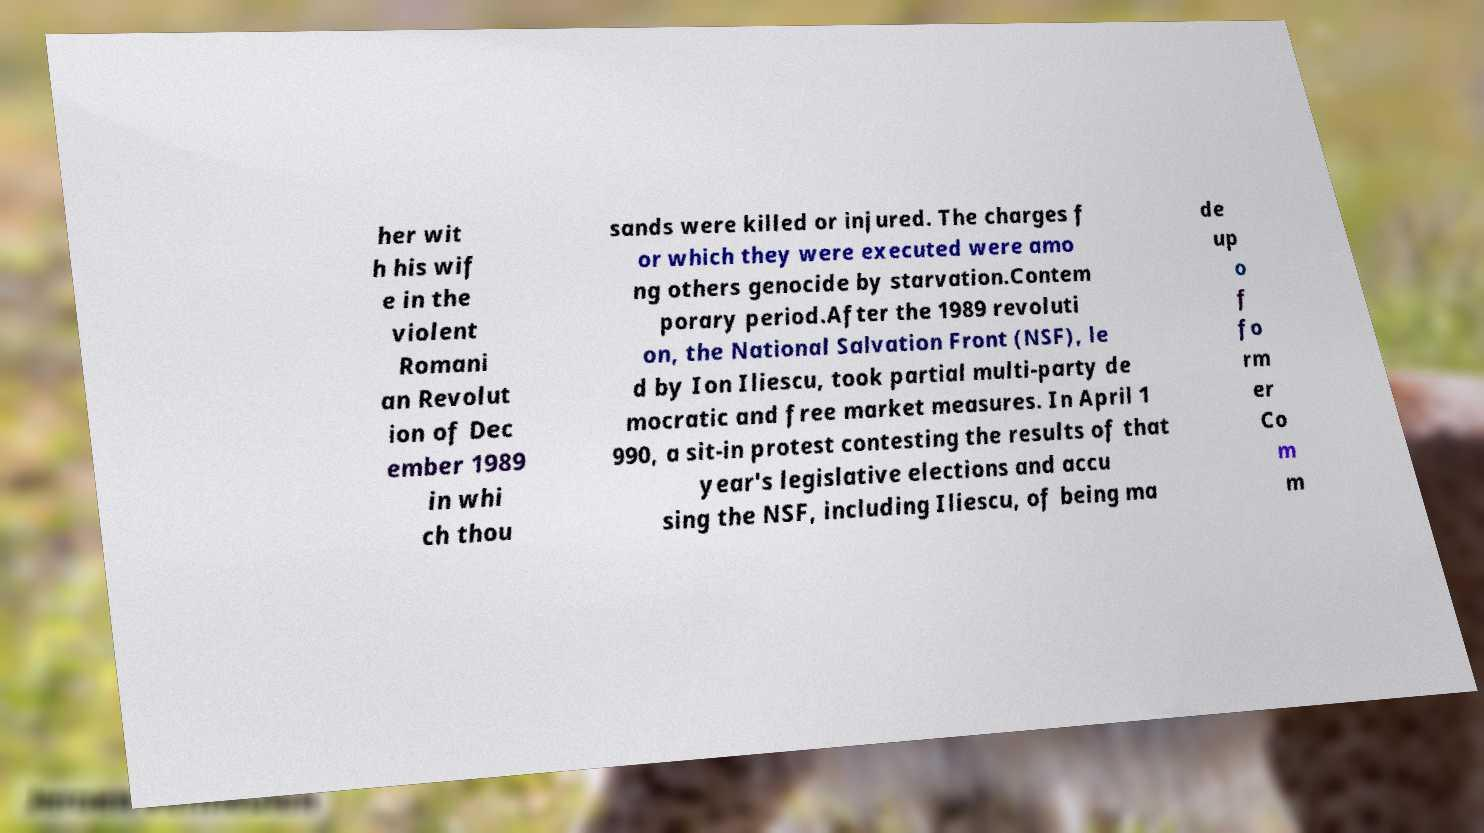Could you extract and type out the text from this image? her wit h his wif e in the violent Romani an Revolut ion of Dec ember 1989 in whi ch thou sands were killed or injured. The charges f or which they were executed were amo ng others genocide by starvation.Contem porary period.After the 1989 revoluti on, the National Salvation Front (NSF), le d by Ion Iliescu, took partial multi-party de mocratic and free market measures. In April 1 990, a sit-in protest contesting the results of that year's legislative elections and accu sing the NSF, including Iliescu, of being ma de up o f fo rm er Co m m 